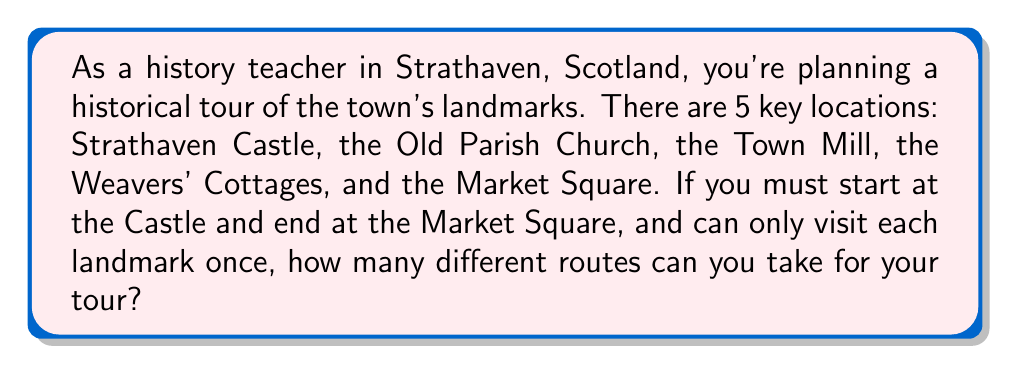Could you help me with this problem? Let's approach this step-by-step using principles of permutations:

1) We start with 5 landmarks, but the start (Strathaven Castle) and end (Market Square) are fixed. This means we only need to determine the order of the middle 3 landmarks.

2) This is a classic permutation problem. We're arranging 3 items (the middle landmarks) in all possible orders.

3) The formula for permutations of $n$ distinct objects is:

   $$P(n) = n!$$

4) In this case, $n = 3$, so we calculate:

   $$P(3) = 3! = 3 \times 2 \times 1 = 6$$

5) Therefore, there are 6 possible ways to arrange the middle 3 landmarks.

6) The complete routes would look like this:
   Castle → (Permutation of 3 landmarks) → Market Square

7) We can list out all possibilities:
   - Castle → Church → Mill → Cottages → Market Square
   - Castle → Church → Cottages → Mill → Market Square
   - Castle → Mill → Church → Cottages → Market Square
   - Castle → Mill → Cottages → Church → Market Square
   - Castle → Cottages → Church → Mill → Market Square
   - Castle → Cottages → Mill → Church → Market Square

Thus, there are 6 different possible routes for the historical tour.
Answer: 6 possible routes 